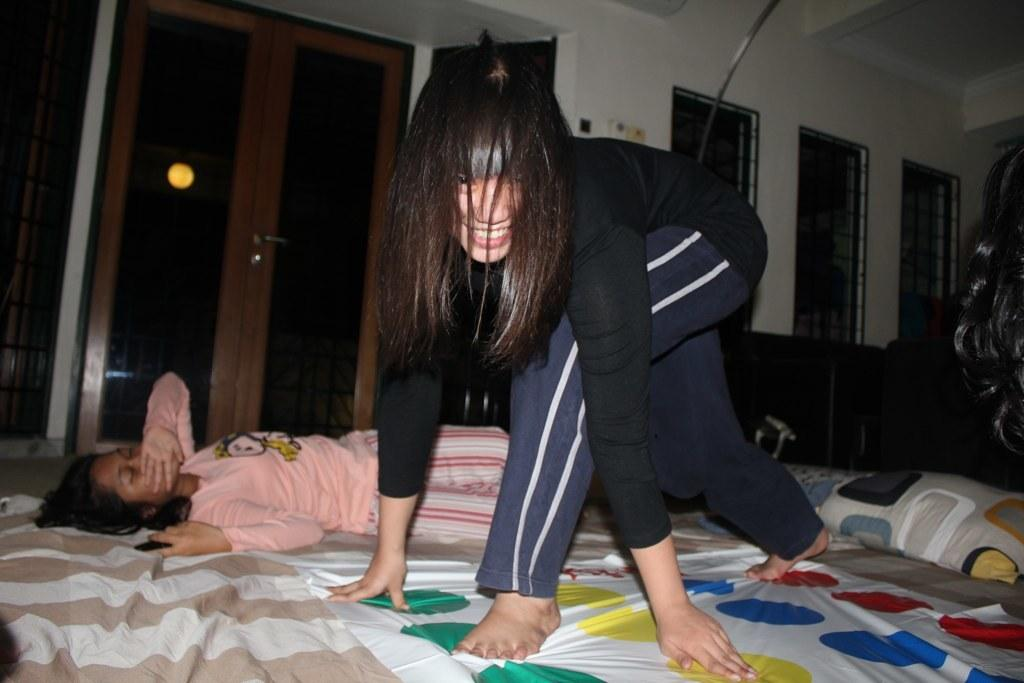How many people are in the image? There are two persons in the image. What is the facial expression of one of the persons? One of the persons is smiling. What type of objects can be seen in the image? There is cloth and pillows in the image. What architectural features are visible in the background of the image? There is a door, light, windows, and a wall in the background of the image. What health advice is the person giving in the image? There is no indication in the image that the person is giving health advice. What wish does the person have for the future in the image? There is no information about the person's wishes in the image. 